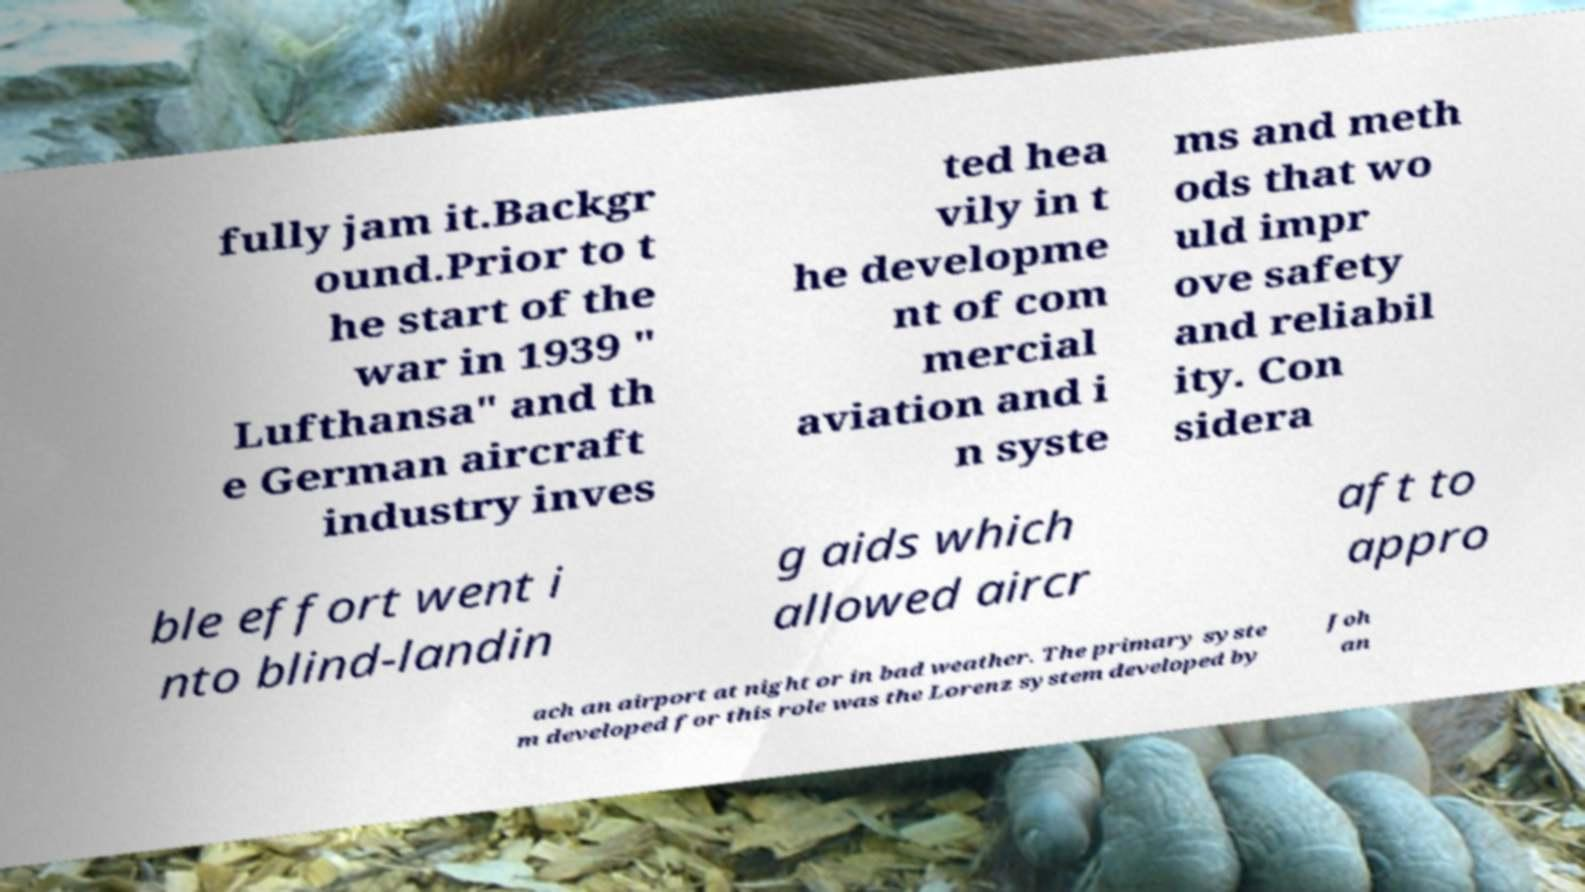Please identify and transcribe the text found in this image. fully jam it.Backgr ound.Prior to t he start of the war in 1939 " Lufthansa" and th e German aircraft industry inves ted hea vily in t he developme nt of com mercial aviation and i n syste ms and meth ods that wo uld impr ove safety and reliabil ity. Con sidera ble effort went i nto blind-landin g aids which allowed aircr aft to appro ach an airport at night or in bad weather. The primary syste m developed for this role was the Lorenz system developed by Joh an 